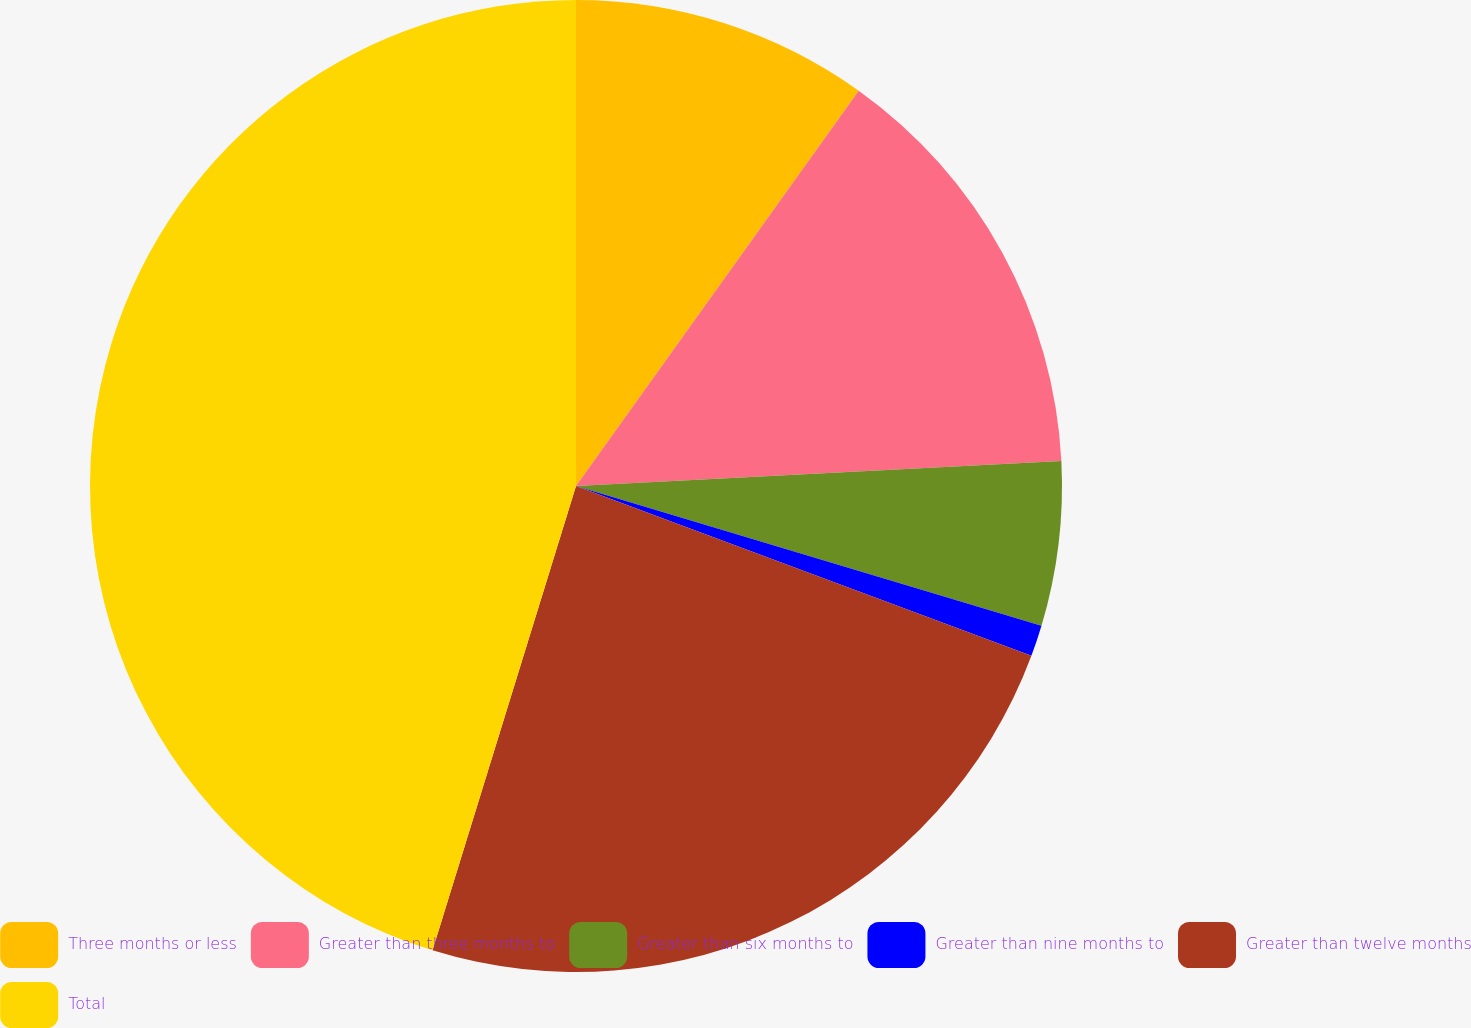Convert chart. <chart><loc_0><loc_0><loc_500><loc_500><pie_chart><fcel>Three months or less<fcel>Greater than three months to<fcel>Greater than six months to<fcel>Greater than nine months to<fcel>Greater than twelve months<fcel>Total<nl><fcel>9.88%<fcel>14.3%<fcel>5.46%<fcel>1.04%<fcel>24.09%<fcel>45.23%<nl></chart> 